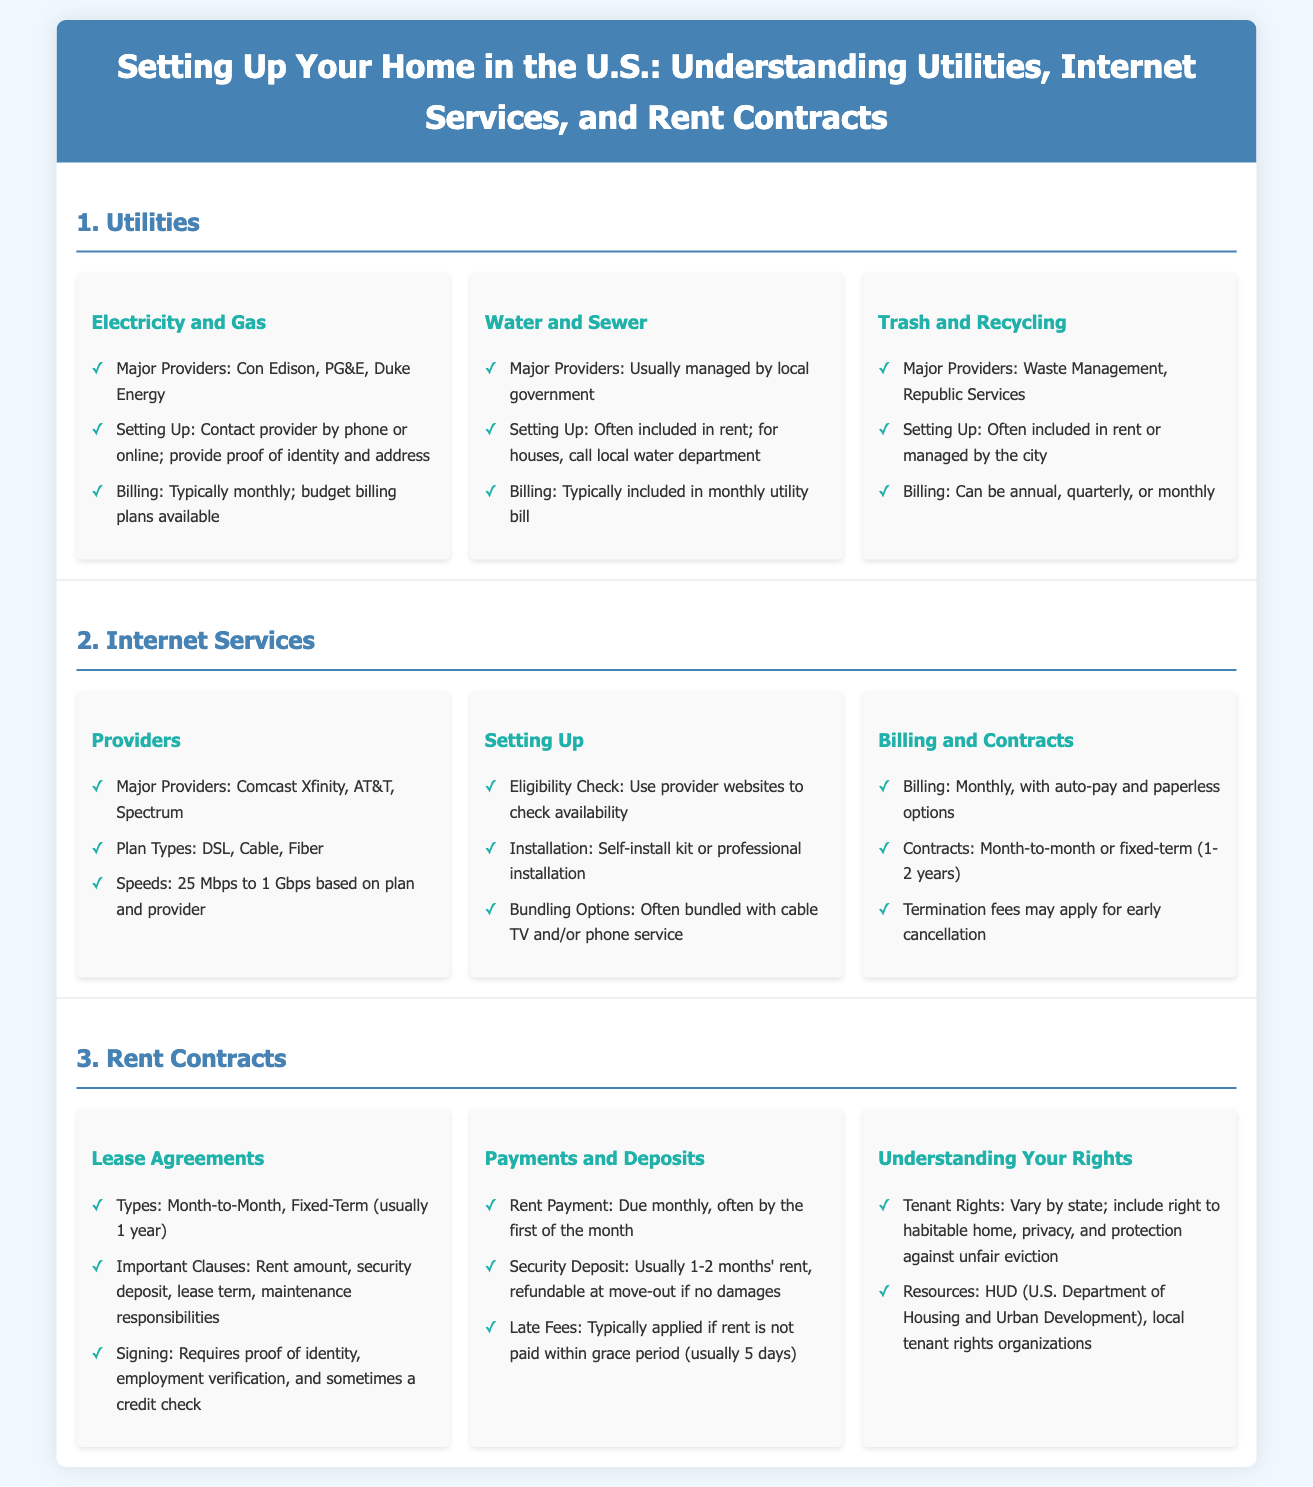what are the major providers of electricity? The document lists major providers of electricity which include Con Edison, PG&E, and Duke Energy.
Answer: Con Edison, PG&E, Duke Energy how is water usually billed? According to the document, water billing is typically included in the monthly utility bill.
Answer: Included in monthly utility bill what types of internet plan does the document mention? The document mentions DSL, Cable, and Fiber as types of internet plans offered by providers.
Answer: DSL, Cable, Fiber what is the typical length of a fixed-term lease? The document indicates that fixed-term leases are usually for 1 year.
Answer: 1 year what can late fees apply to? The document states that late fees typically apply if rent is not paid within the grace period.
Answer: Rent payment who is responsible for understanding tenant rights? The document notes that understanding tenant rights is the responsibility of tenants, and resources are available through HUD and local organizations.
Answer: Tenants what is often included in rent related to trash? The document mentions that trash and recycling services are often included in rent.
Answer: Included in rent what is the range of internet speeds according to the document? The document states that internet speeds range from 25 Mbps to 1 Gbps based on the plan and provider.
Answer: 25 Mbps to 1 Gbps 